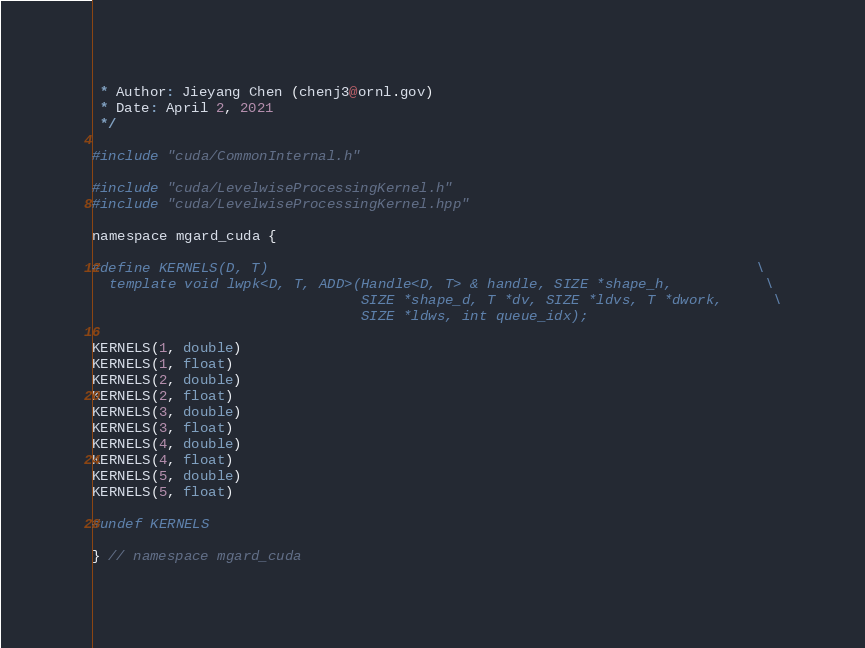<code> <loc_0><loc_0><loc_500><loc_500><_Cuda_> * Author: Jieyang Chen (chenj3@ornl.gov)
 * Date: April 2, 2021
 */

#include "cuda/CommonInternal.h"
 
#include "cuda/LevelwiseProcessingKernel.h"
#include "cuda/LevelwiseProcessingKernel.hpp"

namespace mgard_cuda {

#define KERNELS(D, T)                                                          \
  template void lwpk<D, T, ADD>(Handle<D, T> & handle, SIZE *shape_h,           \
                                SIZE *shape_d, T *dv, SIZE *ldvs, T *dwork,      \
                                SIZE *ldws, int queue_idx);

KERNELS(1, double)
KERNELS(1, float)
KERNELS(2, double)
KERNELS(2, float)
KERNELS(3, double)
KERNELS(3, float)
KERNELS(4, double)
KERNELS(4, float)
KERNELS(5, double)
KERNELS(5, float)

#undef KERNELS

} // namespace mgard_cuda</code> 